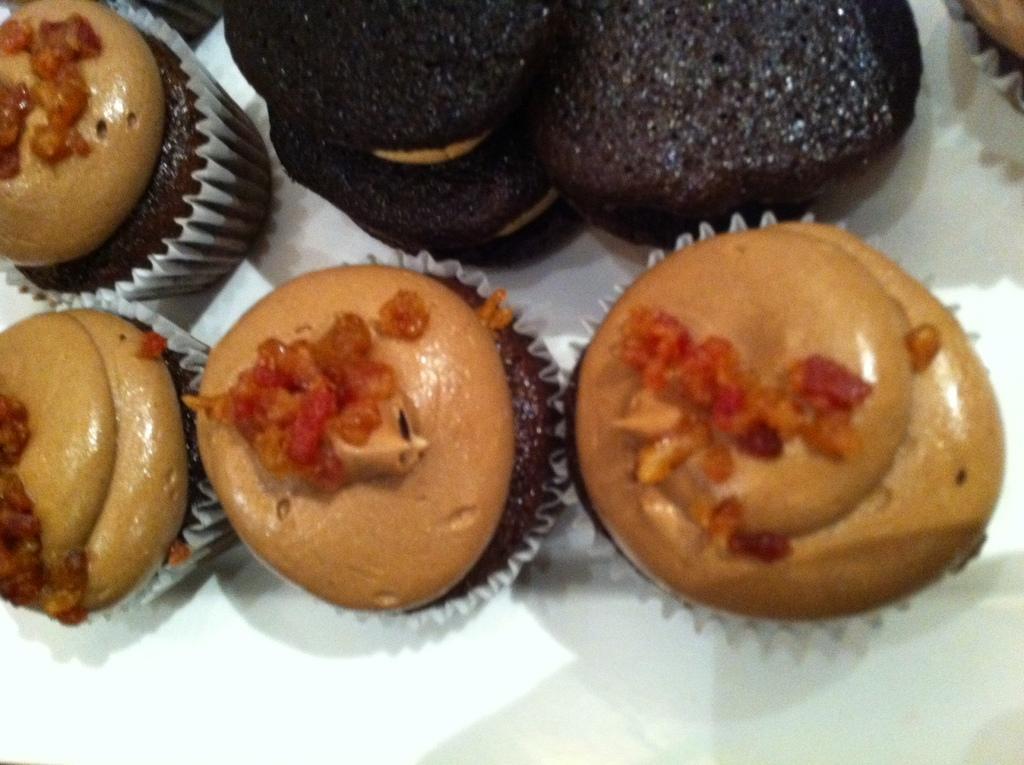Please provide a concise description of this image. Here in this picture we can see number of cupcakes and cookies present on the table over there. 